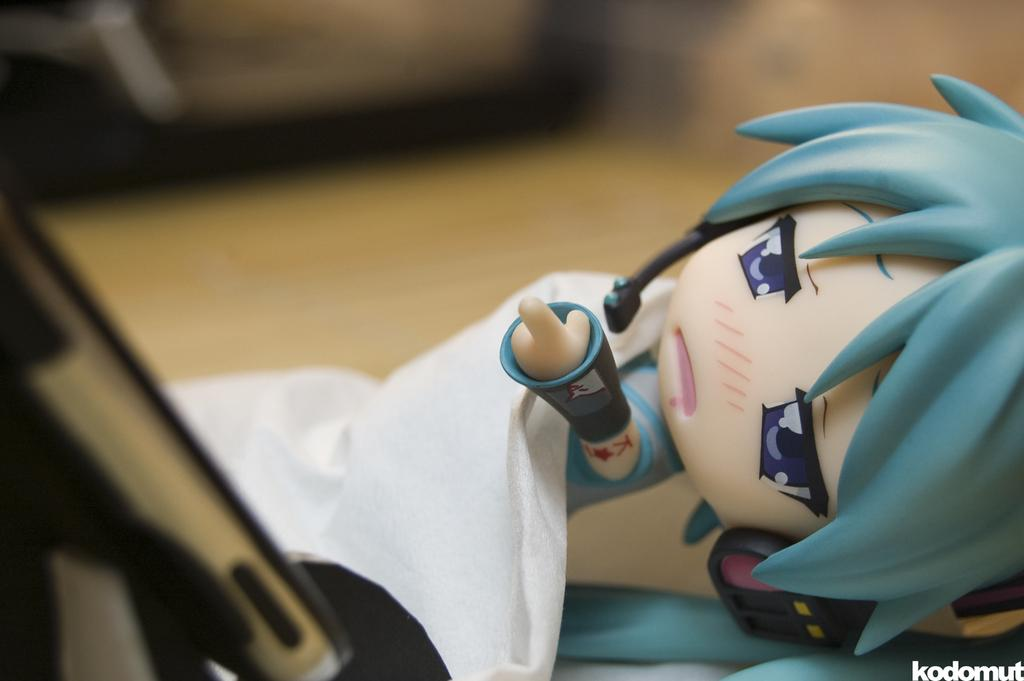What is the main subject of the image? There is a doll in the image. Where is the doll located? The doll is on a table. What type of bridge can be seen in the background of the image? There is no bridge present in the image; it only features a doll on a table. What advertisement is being promoted by the doll in the image? There is no advertisement being promoted by the doll in the image; it is simply a doll on a table. 